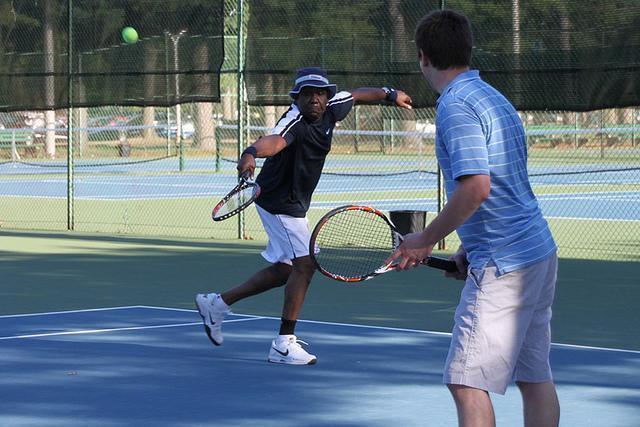How many men in the picture?
Give a very brief answer. 2. How many people are there?
Give a very brief answer. 2. How many giraffes have visible legs?
Give a very brief answer. 0. 